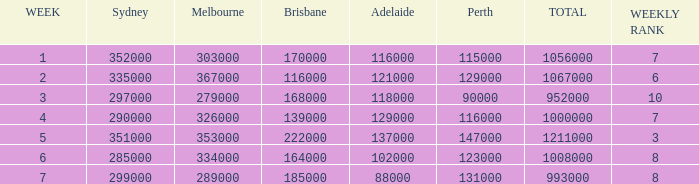What is the maximum number of brisbane spectators? 222000.0. 